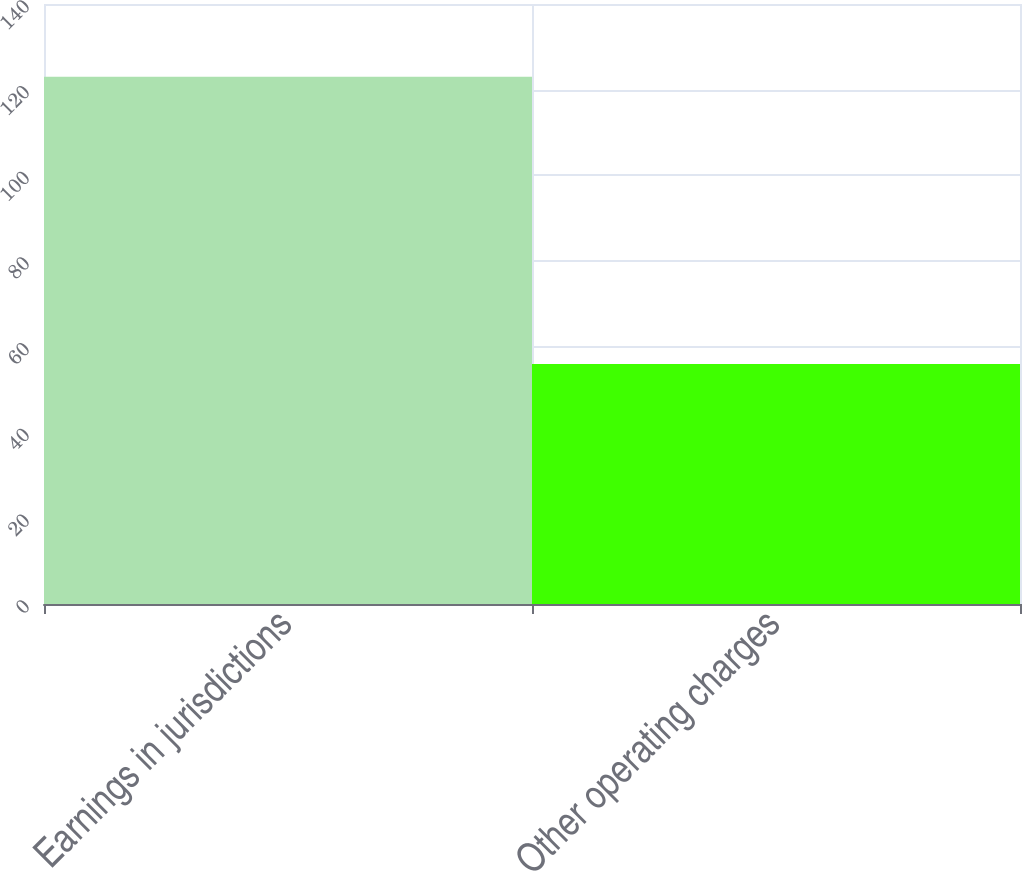Convert chart to OTSL. <chart><loc_0><loc_0><loc_500><loc_500><bar_chart><fcel>Earnings in jurisdictions<fcel>Other operating charges<nl><fcel>123<fcel>56<nl></chart> 